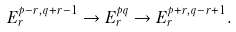Convert formula to latex. <formula><loc_0><loc_0><loc_500><loc_500>E ^ { p - r , q + r - 1 } _ { r } \to E ^ { p q } _ { r } \to E ^ { p + r , q - r + 1 } _ { r } .</formula> 